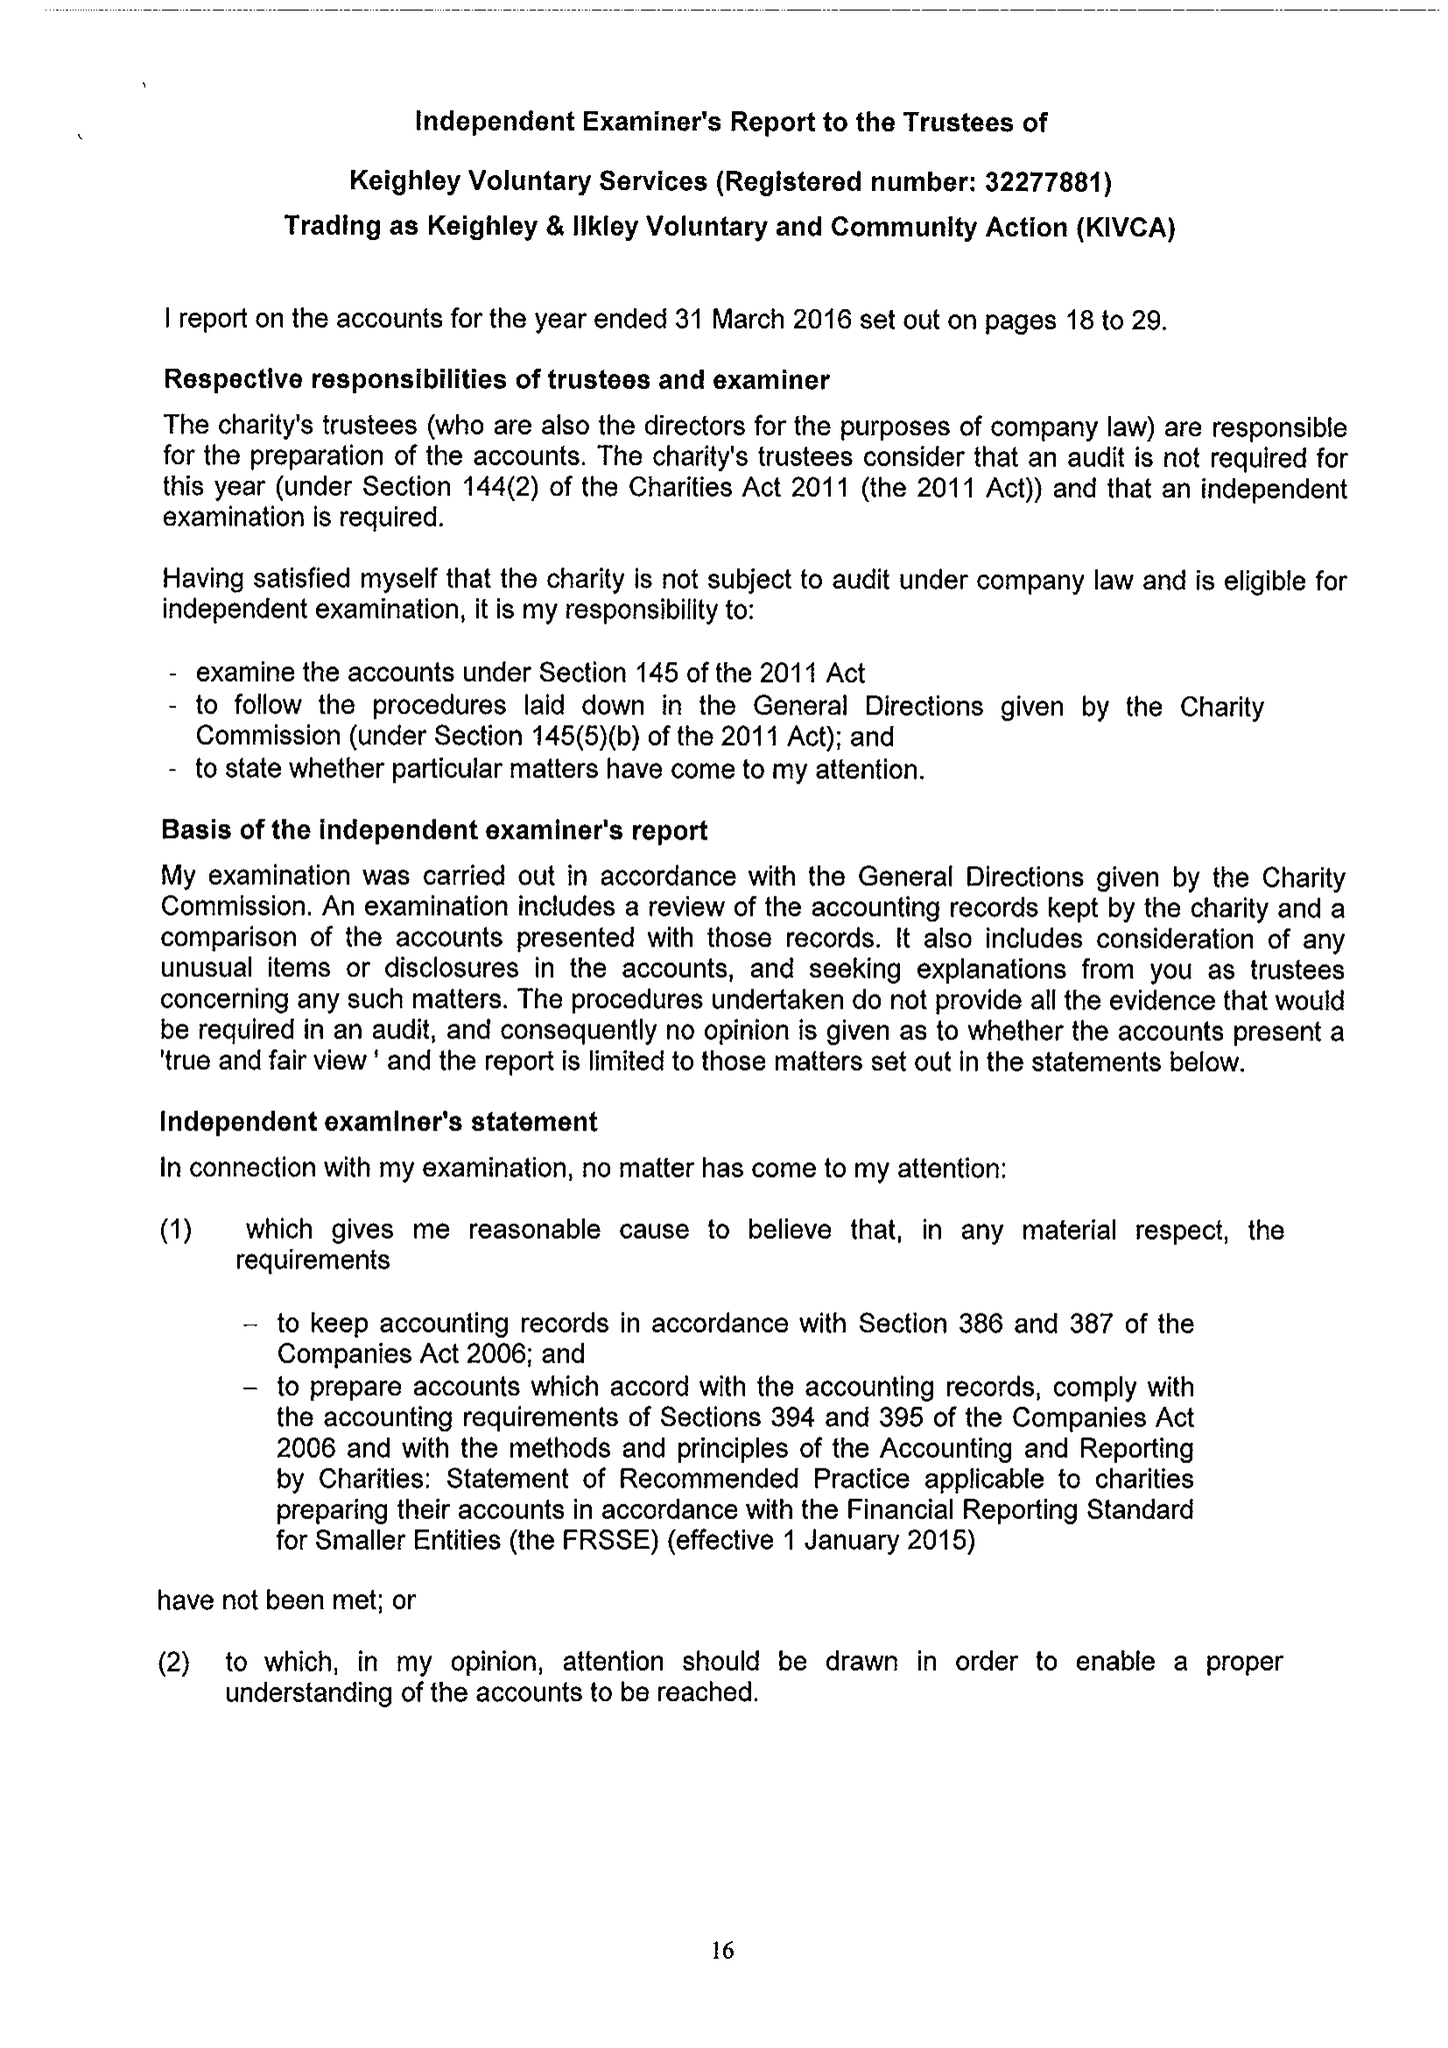What is the value for the address__street_line?
Answer the question using a single word or phrase. ALICE STREET 